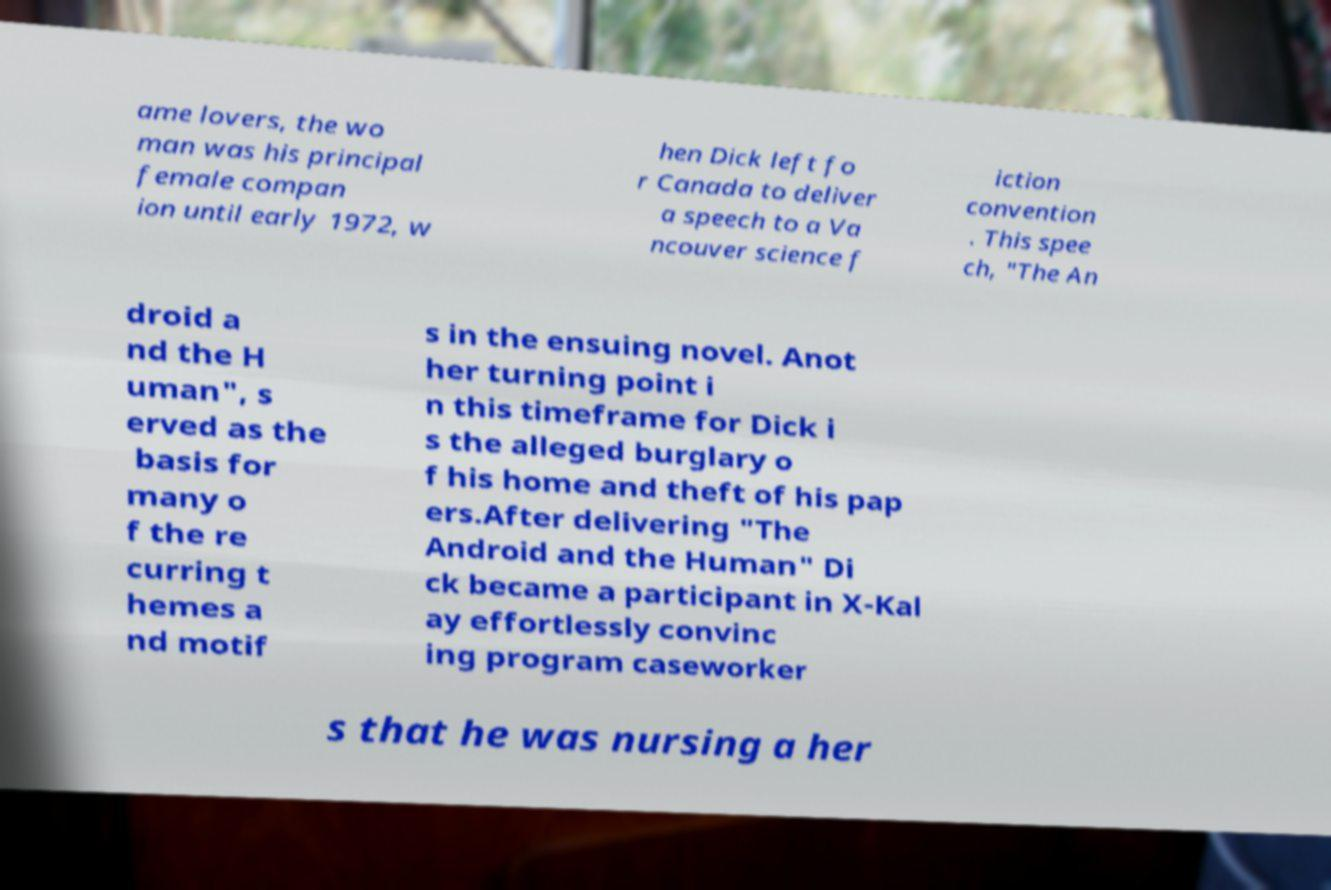Can you accurately transcribe the text from the provided image for me? ame lovers, the wo man was his principal female compan ion until early 1972, w hen Dick left fo r Canada to deliver a speech to a Va ncouver science f iction convention . This spee ch, "The An droid a nd the H uman", s erved as the basis for many o f the re curring t hemes a nd motif s in the ensuing novel. Anot her turning point i n this timeframe for Dick i s the alleged burglary o f his home and theft of his pap ers.After delivering "The Android and the Human" Di ck became a participant in X-Kal ay effortlessly convinc ing program caseworker s that he was nursing a her 